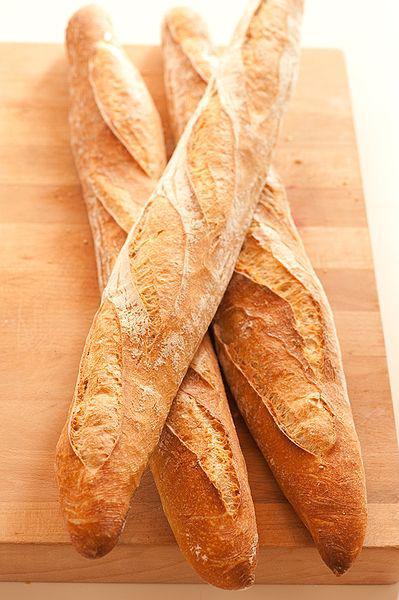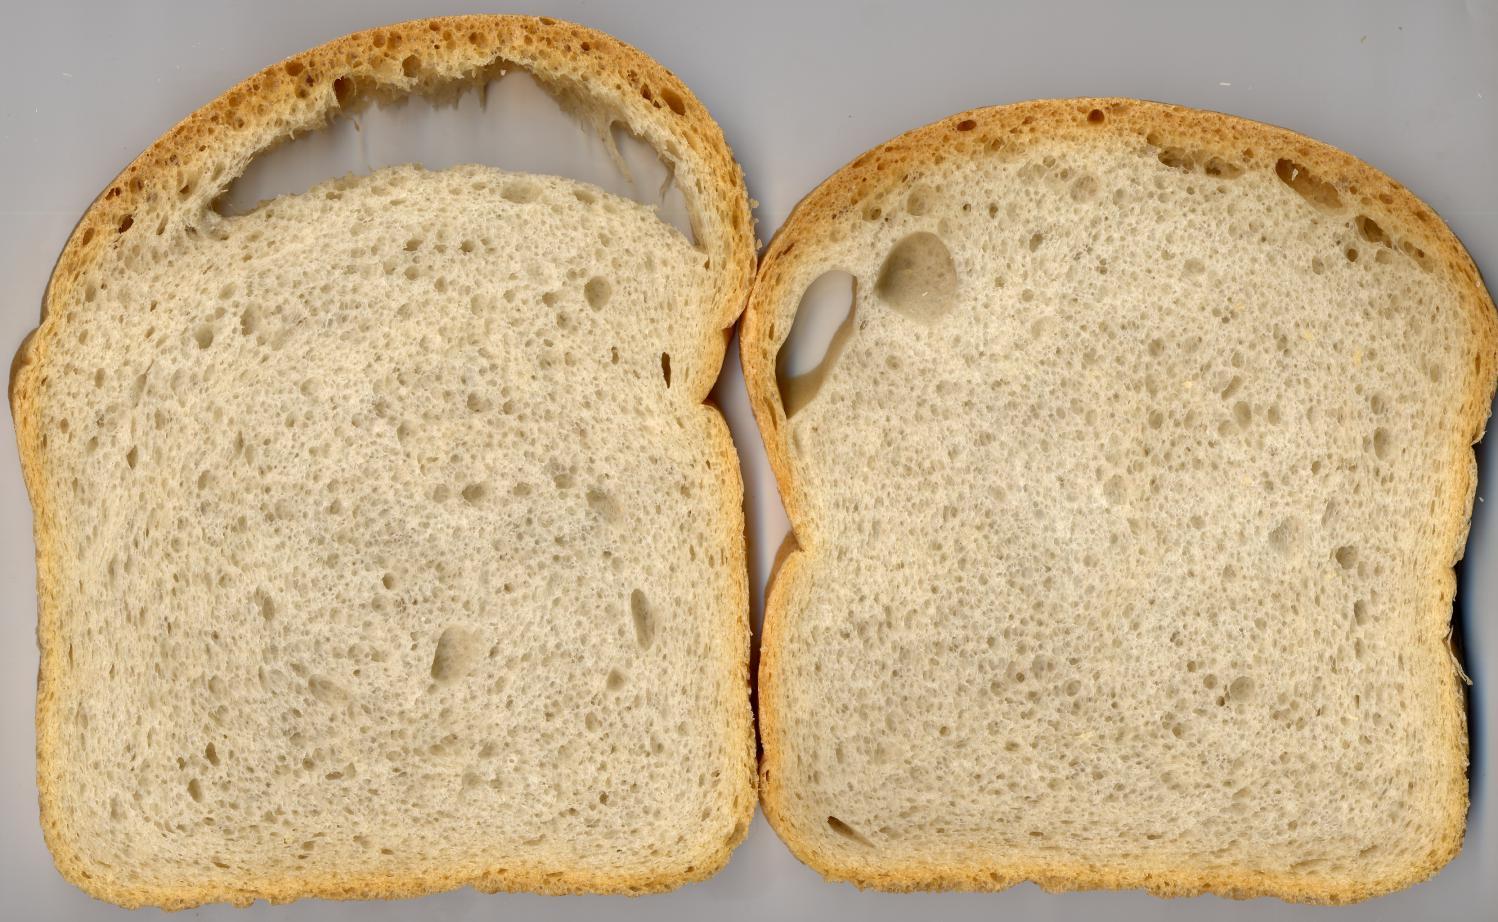The first image is the image on the left, the second image is the image on the right. Evaluate the accuracy of this statement regarding the images: "One image shows a bread loaf with at least one cut slice on a cutting board, and the other image includes multiple whole loaves with diagonal slash marks on top.". Is it true? Answer yes or no. No. 